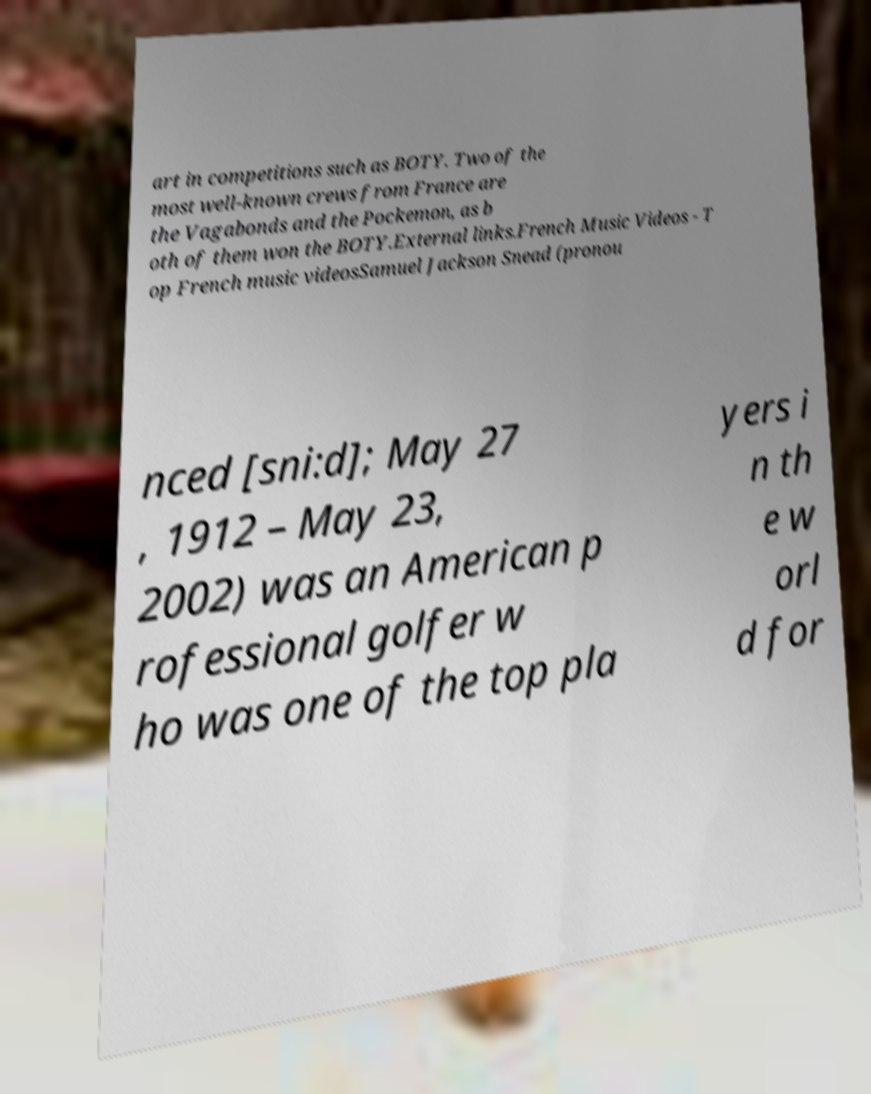Can you accurately transcribe the text from the provided image for me? art in competitions such as BOTY. Two of the most well-known crews from France are the Vagabonds and the Pockemon, as b oth of them won the BOTY.External links.French Music Videos - T op French music videosSamuel Jackson Snead (pronou nced [sni:d]; May 27 , 1912 – May 23, 2002) was an American p rofessional golfer w ho was one of the top pla yers i n th e w orl d for 